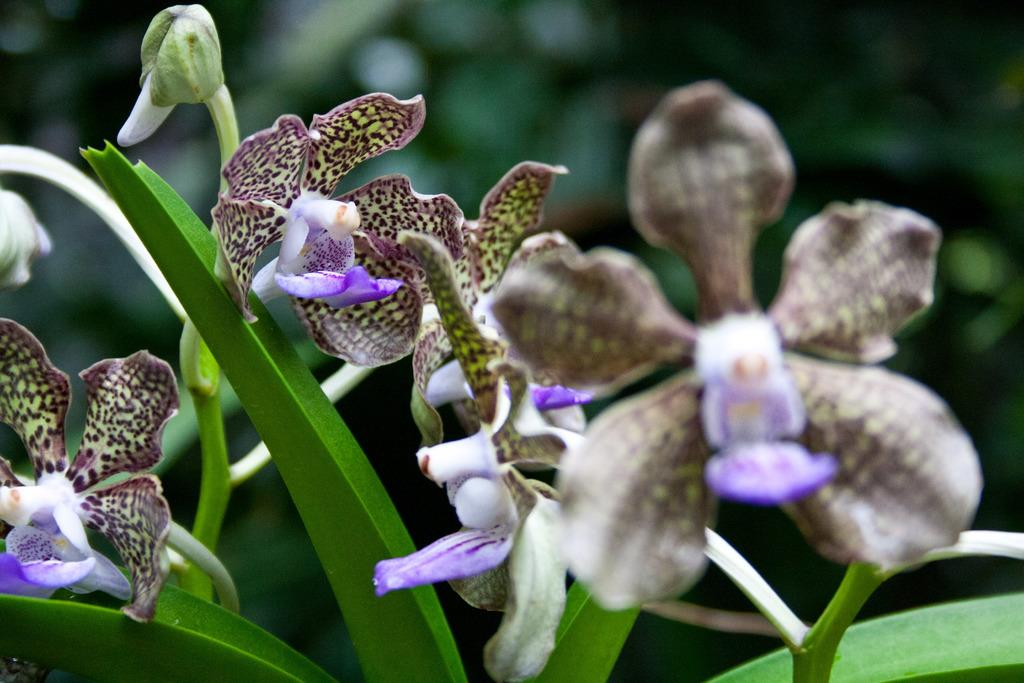What type of plants can be seen in the image? There are flowers and leaves in the image. What can be observed about the background of the image? The background of the image is blurred. How many geese are visible in the image? There are no geese present in the image. What type of bag is being used to carry the flowers in the image? There is no bag present in the image, as it only features flowers and leaves. 